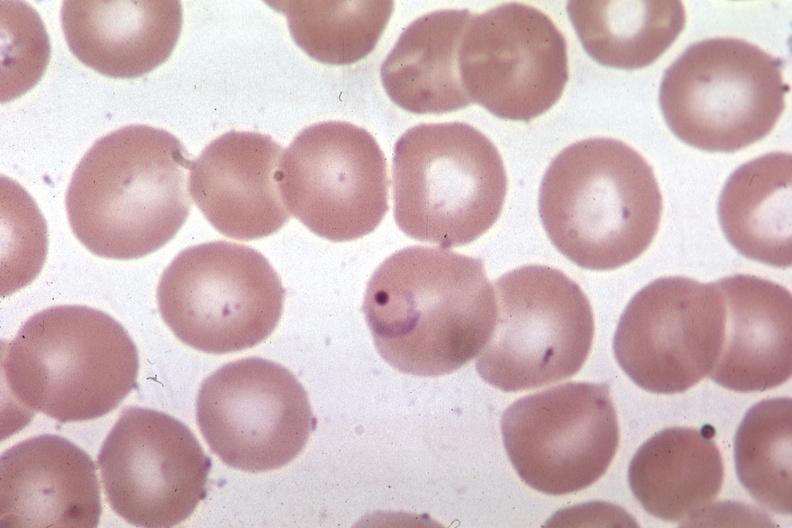s typical tuberculous exudate present?
Answer the question using a single word or phrase. No 